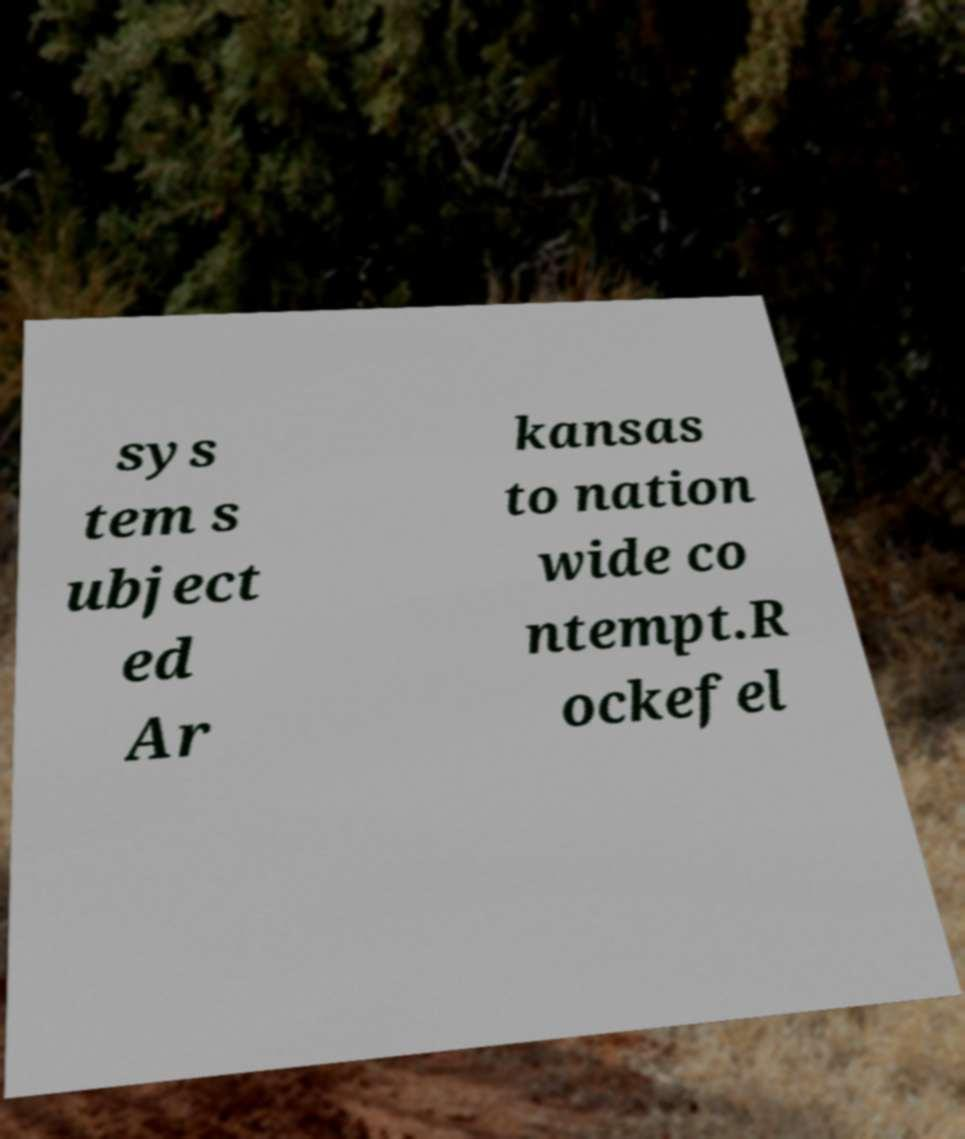Can you read and provide the text displayed in the image?This photo seems to have some interesting text. Can you extract and type it out for me? sys tem s ubject ed Ar kansas to nation wide co ntempt.R ockefel 